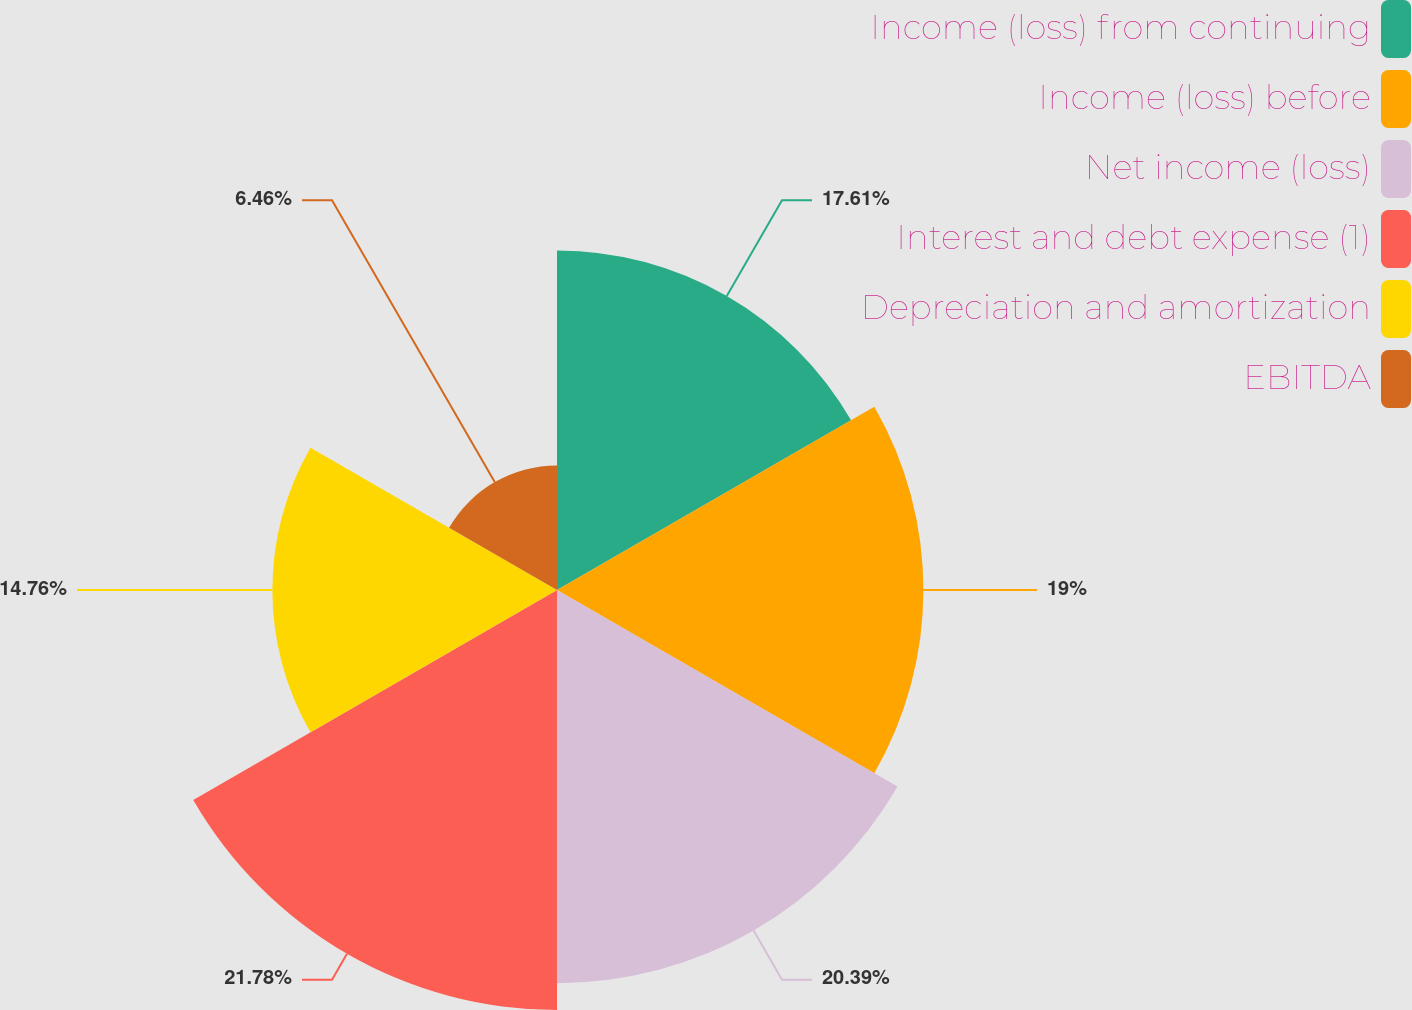Convert chart. <chart><loc_0><loc_0><loc_500><loc_500><pie_chart><fcel>Income (loss) from continuing<fcel>Income (loss) before<fcel>Net income (loss)<fcel>Interest and debt expense (1)<fcel>Depreciation and amortization<fcel>EBITDA<nl><fcel>17.61%<fcel>19.0%<fcel>20.39%<fcel>21.78%<fcel>14.76%<fcel>6.46%<nl></chart> 